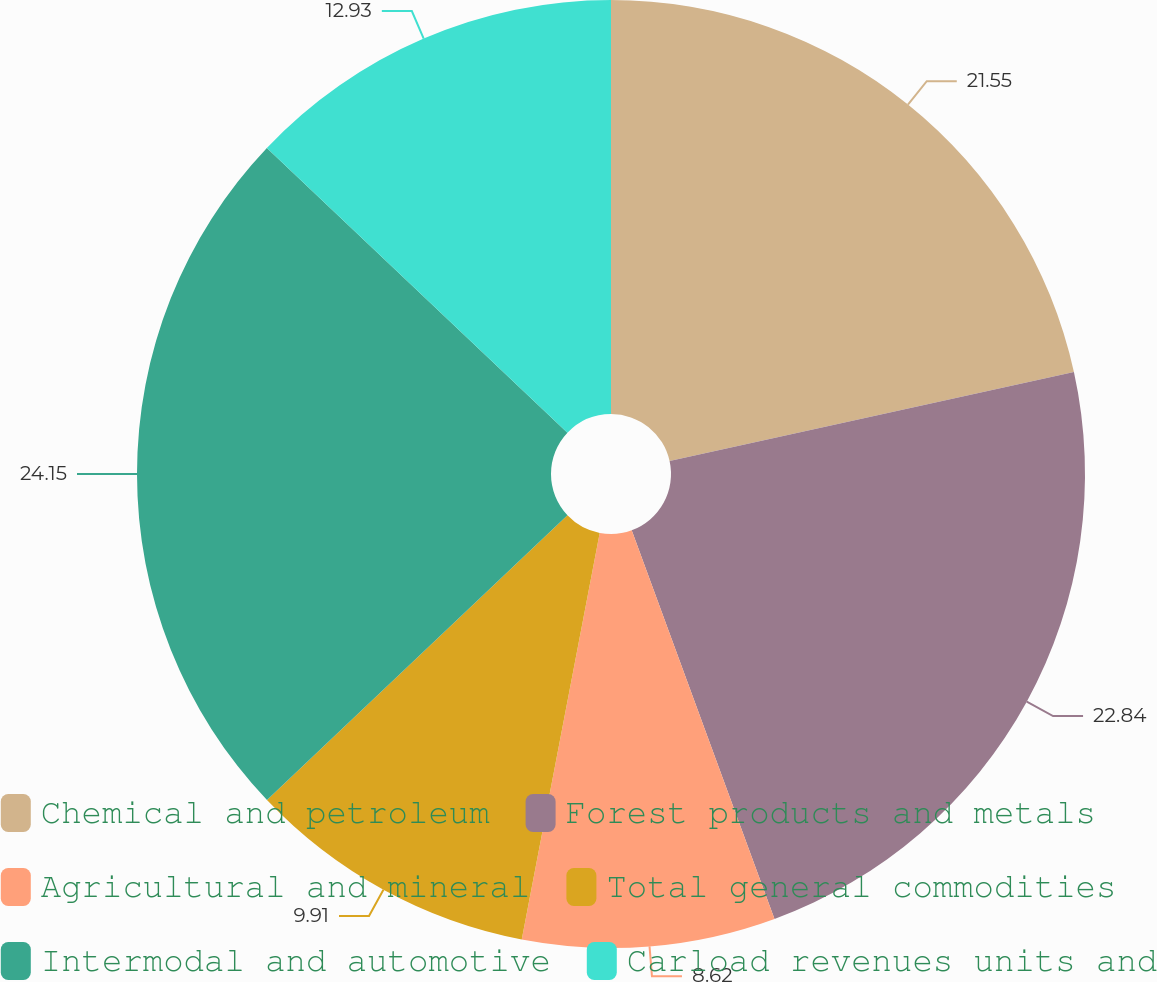Convert chart to OTSL. <chart><loc_0><loc_0><loc_500><loc_500><pie_chart><fcel>Chemical and petroleum<fcel>Forest products and metals<fcel>Agricultural and mineral<fcel>Total general commodities<fcel>Intermodal and automotive<fcel>Carload revenues units and<nl><fcel>21.55%<fcel>22.84%<fcel>8.62%<fcel>9.91%<fcel>24.14%<fcel>12.93%<nl></chart> 